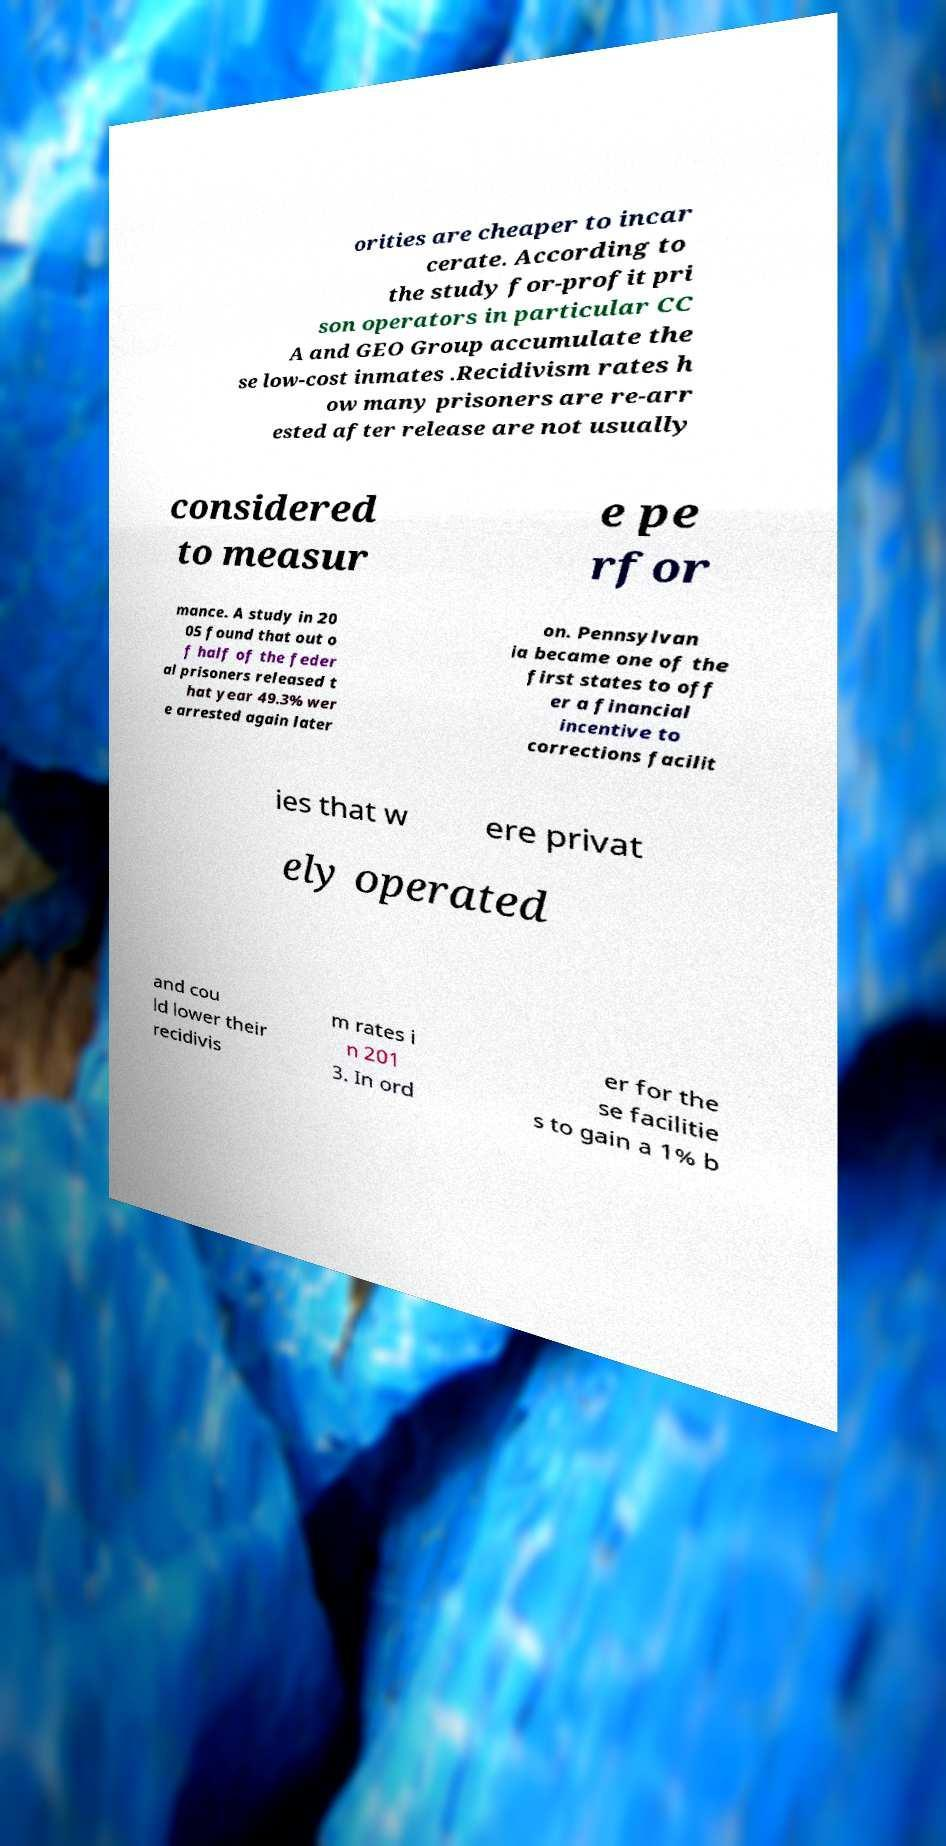Can you read and provide the text displayed in the image?This photo seems to have some interesting text. Can you extract and type it out for me? orities are cheaper to incar cerate. According to the study for-profit pri son operators in particular CC A and GEO Group accumulate the se low-cost inmates .Recidivism rates h ow many prisoners are re-arr ested after release are not usually considered to measur e pe rfor mance. A study in 20 05 found that out o f half of the feder al prisoners released t hat year 49.3% wer e arrested again later on. Pennsylvan ia became one of the first states to off er a financial incentive to corrections facilit ies that w ere privat ely operated and cou ld lower their recidivis m rates i n 201 3. In ord er for the se facilitie s to gain a 1% b 